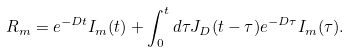Convert formula to latex. <formula><loc_0><loc_0><loc_500><loc_500>R _ { m } = e ^ { - D t } I _ { m } ( t ) + \int _ { 0 } ^ { t } d \tau J _ { D } ( t - \tau ) e ^ { - D \tau } I _ { m } ( \tau ) .</formula> 